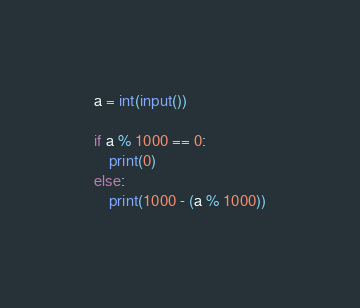Convert code to text. <code><loc_0><loc_0><loc_500><loc_500><_Python_>a = int(input())

if a % 1000 == 0:
    print(0)
else:
    print(1000 - (a % 1000))</code> 